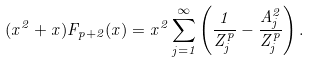Convert formula to latex. <formula><loc_0><loc_0><loc_500><loc_500>( x ^ { 2 } + x ) F _ { p + 2 } ( x ) = x ^ { 2 } \sum _ { j = 1 } ^ { \infty } \left ( \frac { 1 } { Z _ { j } ^ { p } } - \frac { A _ { j } ^ { 2 } } { Z _ { j } ^ { p } } \right ) .</formula> 